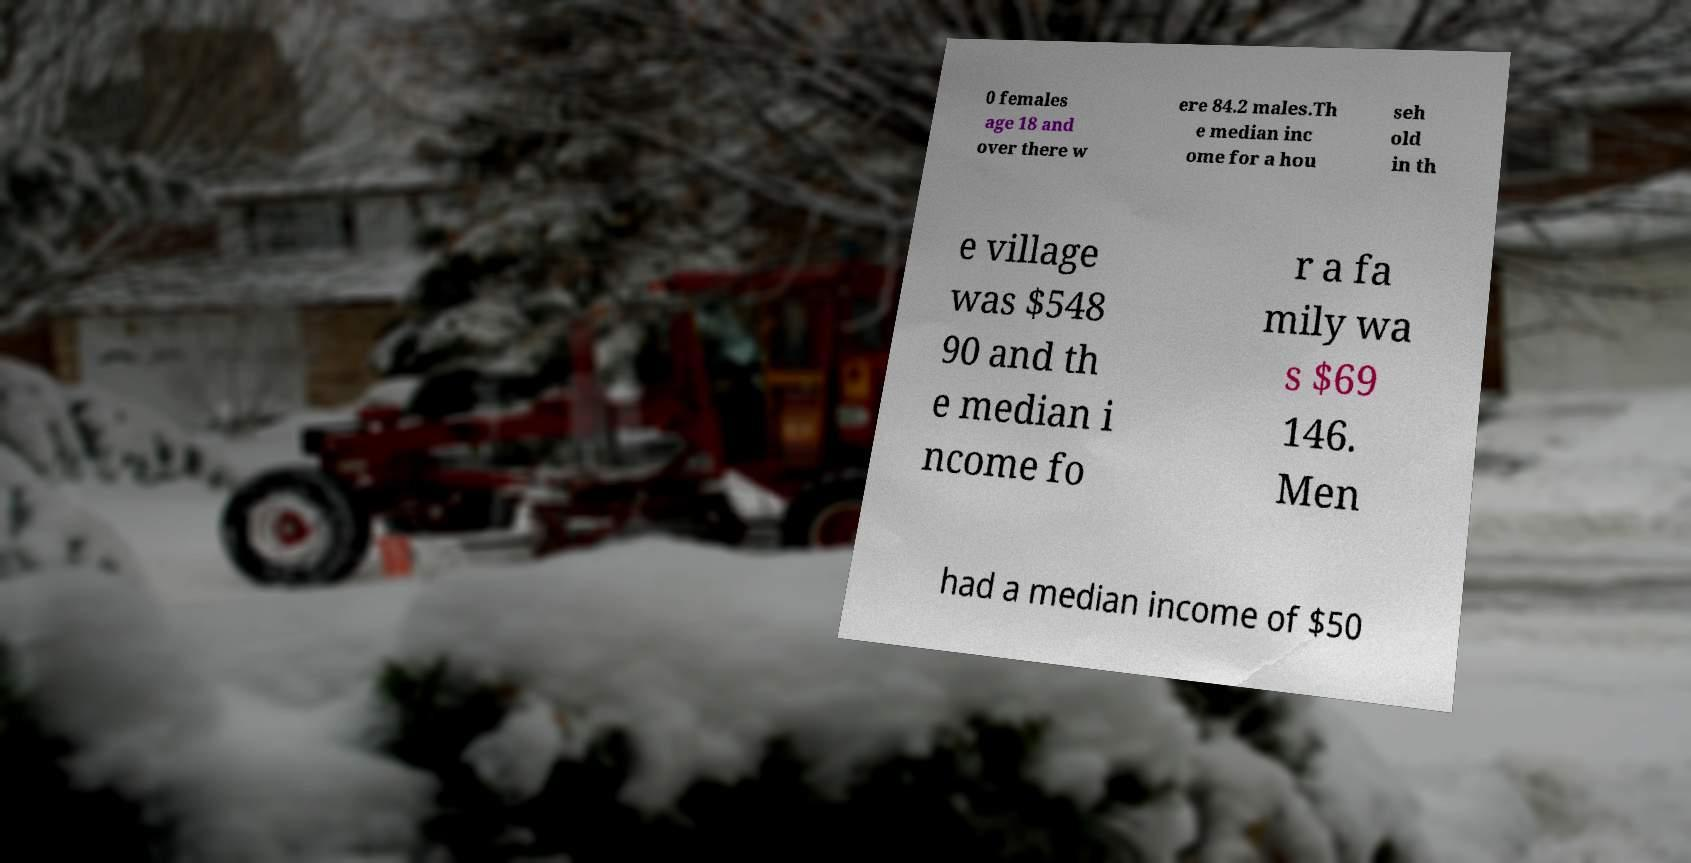For documentation purposes, I need the text within this image transcribed. Could you provide that? 0 females age 18 and over there w ere 84.2 males.Th e median inc ome for a hou seh old in th e village was $548 90 and th e median i ncome fo r a fa mily wa s $69 146. Men had a median income of $50 